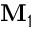<formula> <loc_0><loc_0><loc_500><loc_500>M _ { 1 }</formula> 